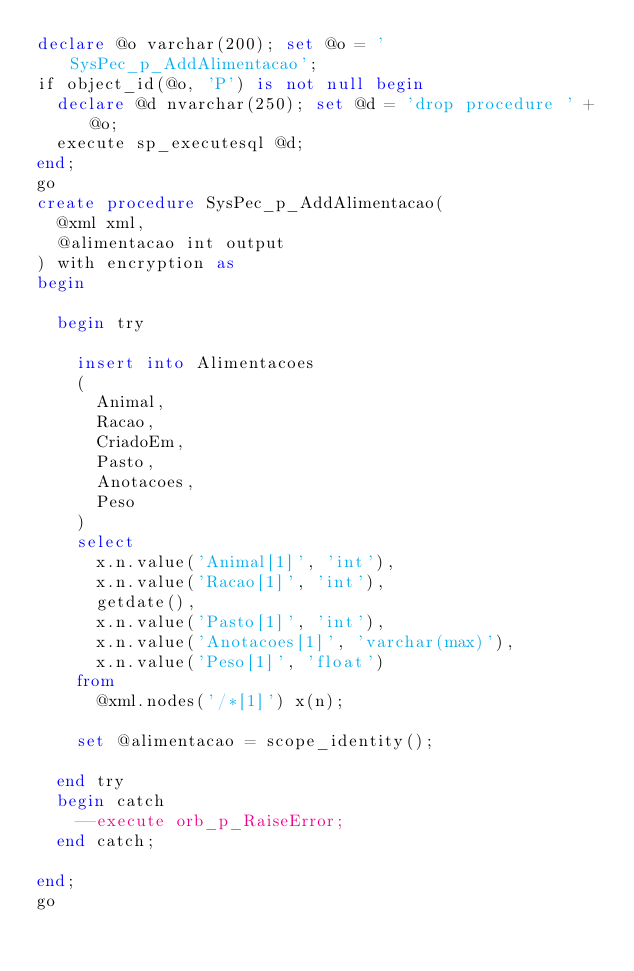<code> <loc_0><loc_0><loc_500><loc_500><_SQL_>declare @o varchar(200); set @o = 'SysPec_p_AddAlimentacao';
if object_id(@o, 'P') is not null begin
	declare @d nvarchar(250); set @d = 'drop procedure ' + @o;
	execute sp_executesql @d;
end;
go
create procedure SysPec_p_AddAlimentacao(
	@xml xml,
	@alimentacao int output
) with encryption as
begin

	begin try

		insert into Alimentacoes 
		(
			Animal,
			Racao,
			CriadoEm,
			Pasto,
			Anotacoes,
			Peso
		)
		select
			x.n.value('Animal[1]', 'int'),
			x.n.value('Racao[1]', 'int'),
			getdate(),
			x.n.value('Pasto[1]', 'int'),
			x.n.value('Anotacoes[1]', 'varchar(max)'),
			x.n.value('Peso[1]', 'float')
		from
			@xml.nodes('/*[1]') x(n);

		set @alimentacao = scope_identity();

	end try
	begin catch
		--execute orb_p_RaiseError;
	end catch;

end;
go</code> 